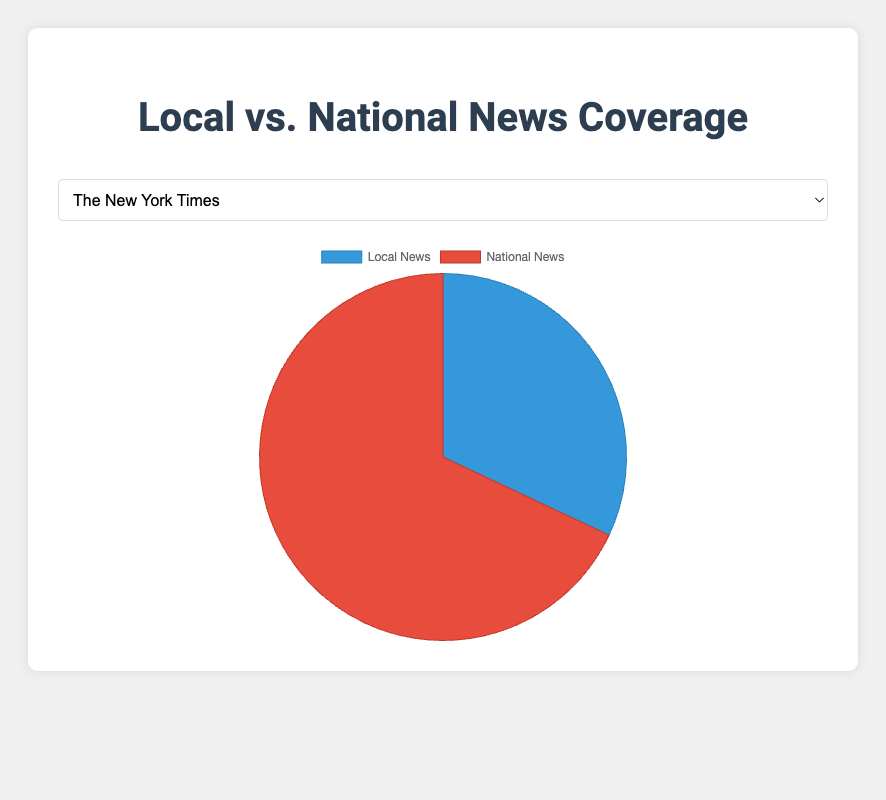What is the proportion of local news articles to the total number of articles for The New York Times? The total number of articles for The New York Times is 320 (local) + 680 (national) = 1000. The proportion of local news articles is 320/1000 = 0.32 or 32%
Answer: 32% Which newspaper has an equal number of local and national news articles? Look for the newspaper where the counts of local and national news articles are the same. In this case, Chicago Tribune has 500 articles for both local and national news
Answer: Chicago Tribune Compare the local news coverage between The New York Times and Miami Herald. Which newspaper has more local news articles, and by how many? The New York Times has 320 local news articles, and Miami Herald has 380 local news articles. The difference is 380 - 320 = 60. Therefore, the Miami Herald has 60 more local news articles
Answer: Miami Herald by 60 What is the total number of articles in San Francisco Chronicle and Los Angeles Times combined? San Francisco Chronicle has 450 (local) + 550 (national) = 1000 articles and Los Angeles Times has 420 (local) + 580 (national) = 1000 articles. Combined total is 1000 + 1000 = 2000 articles
Answer: 2000 Between San Francisco Chronicle and Miami Herald, which newspaper has a higher percentage of national news articles? San Francisco Chronicle has 550/1000 = 55% national news articles. Miami Herald has 620/1000 = 62% national news articles. Therefore, Miami Herald has the higher percentage
Answer: Miami Herald What is the difference in the proportion of local news articles between Chicago Tribune and Los Angeles Times? Chicago Tribune has 500 (local) out of 1000 total articles, so the proportion is 50%. Los Angeles Times has 420 (local) out of 1000 total articles, so the proportion is 42%. The difference is 50% - 42% = 8%
Answer: 8% Which newspaper has the smallest proportion of local news articles? Calculate the proportion of local news for each newspaper and compare:
- The New York Times: 320/1000 = 32%
- San Francisco Chronicle: 450/1000 = 45%
- Chicago Tribune: 500/1000 = 50%
- Los Angeles Times: 420/1000 = 42%
- Miami Herald: 380/1000 = 38%
The smallest proportion is 32% from The New York Times
Answer: The New York Times 